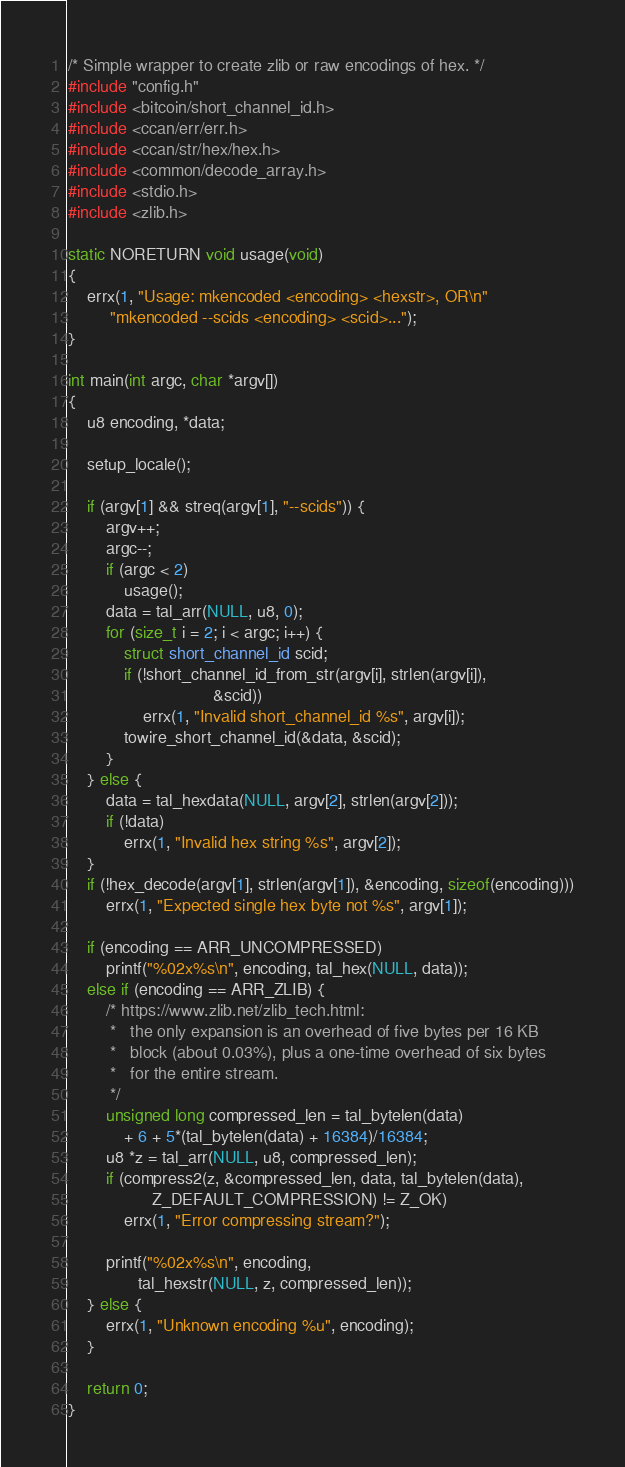Convert code to text. <code><loc_0><loc_0><loc_500><loc_500><_C_>/* Simple wrapper to create zlib or raw encodings of hex. */
#include "config.h"
#include <bitcoin/short_channel_id.h>
#include <ccan/err/err.h>
#include <ccan/str/hex/hex.h>
#include <common/decode_array.h>
#include <stdio.h>
#include <zlib.h>

static NORETURN void usage(void)
{
	errx(1, "Usage: mkencoded <encoding> <hexstr>, OR\n"
	     "mkencoded --scids <encoding> <scid>...");
}

int main(int argc, char *argv[])
{
	u8 encoding, *data;

	setup_locale();

	if (argv[1] && streq(argv[1], "--scids")) {
		argv++;
		argc--;
		if (argc < 2)
			usage();
		data = tal_arr(NULL, u8, 0);
		for (size_t i = 2; i < argc; i++) {
			struct short_channel_id scid;
			if (!short_channel_id_from_str(argv[i], strlen(argv[i]),
						       &scid))
				errx(1, "Invalid short_channel_id %s", argv[i]);
			towire_short_channel_id(&data, &scid);
		}
	} else {
		data = tal_hexdata(NULL, argv[2], strlen(argv[2]));
		if (!data)
			errx(1, "Invalid hex string %s", argv[2]);
	}
	if (!hex_decode(argv[1], strlen(argv[1]), &encoding, sizeof(encoding)))
		errx(1, "Expected single hex byte not %s", argv[1]);

	if (encoding == ARR_UNCOMPRESSED)
		printf("%02x%s\n", encoding, tal_hex(NULL, data));
	else if (encoding == ARR_ZLIB) {
		/* https://www.zlib.net/zlib_tech.html:
		 *   the only expansion is an overhead of five bytes per 16 KB
		 *   block (about 0.03%), plus a one-time overhead of six bytes
		 *   for the entire stream.
		 */
		unsigned long compressed_len = tal_bytelen(data)
			+ 6 + 5*(tal_bytelen(data) + 16384)/16384;
		u8 *z = tal_arr(NULL, u8, compressed_len);
		if (compress2(z, &compressed_len, data, tal_bytelen(data),
			      Z_DEFAULT_COMPRESSION) != Z_OK)
			errx(1, "Error compressing stream?");

		printf("%02x%s\n", encoding,
		       tal_hexstr(NULL, z, compressed_len));
	} else {
		errx(1, "Unknown encoding %u", encoding);
	}

	return 0;
}
</code> 